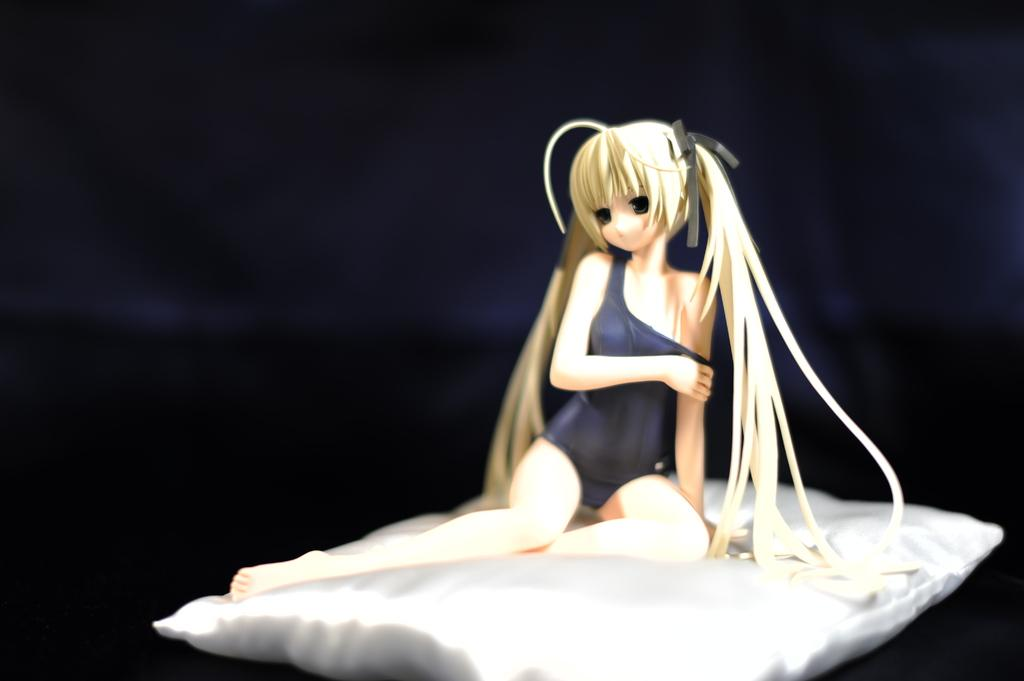What type of image is being described? The image is animated. What can be seen at the bottom of the image? There is a white color mattress at the bottom of the image. Who or what is sitting on the mattress? There is a girl sitting on the mattress. What type of territory is being claimed by the girl in the image? There is no indication in the image that the girl is claiming any territory. 